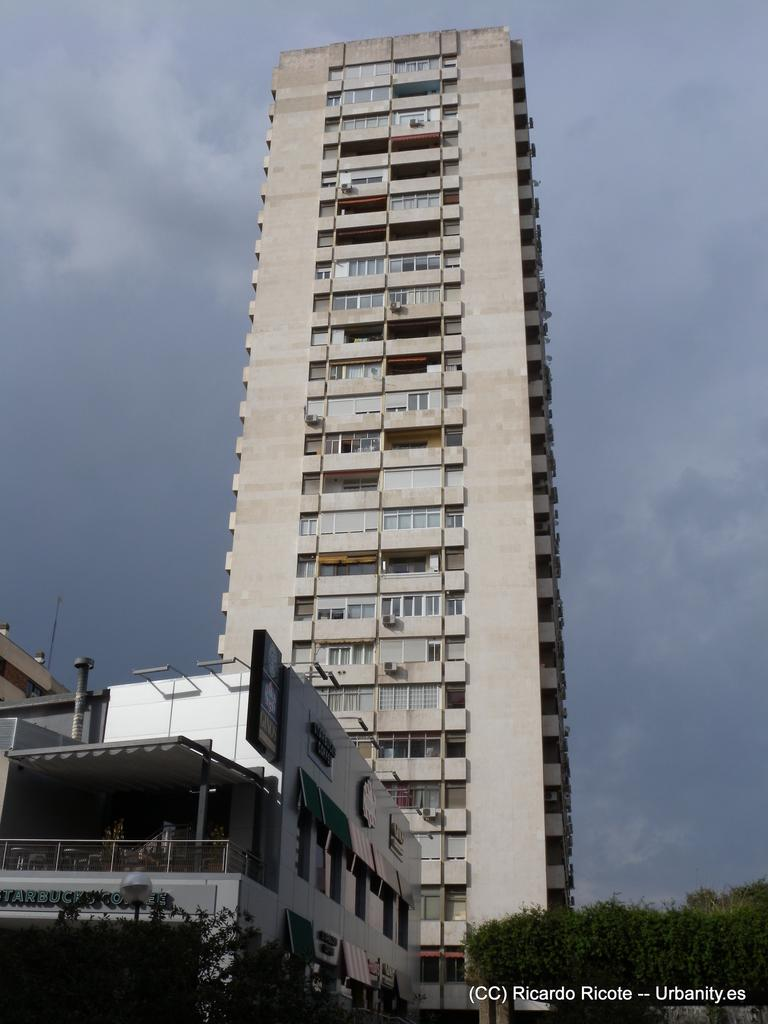What type of structures are present in the image? There are buildings with walls and windows in the image. Can you describe any specific architectural features in the image? There is a railing in the image. What type of natural elements can be seen in the image? There are trees in the image. What is visible in the background of the image? The sky is visible in the background of the image. Is there any additional information or markings on the image? There is a watermark on the right side bottom of the image. Can you tell me how many yaks are grazing in the field in the image? There are no yaks or fields present in the image; it features buildings, trees, and a railing. 